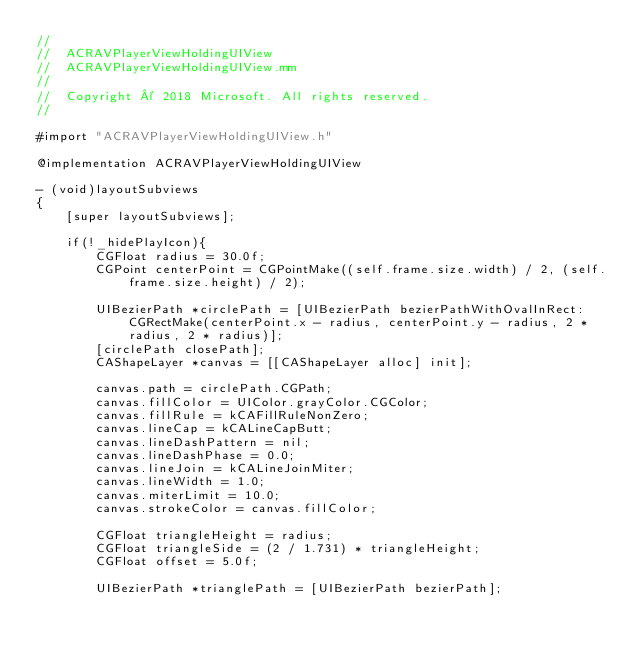<code> <loc_0><loc_0><loc_500><loc_500><_ObjectiveC_>//
//  ACRAVPlayerViewHoldingUIView
//  ACRAVPlayerViewHoldingUIView.mm
//
//  Copyright © 2018 Microsoft. All rights reserved.
//

#import "ACRAVPlayerViewHoldingUIView.h"

@implementation ACRAVPlayerViewHoldingUIView

- (void)layoutSubviews
{
    [super layoutSubviews];

    if(!_hidePlayIcon){
        CGFloat radius = 30.0f;
        CGPoint centerPoint = CGPointMake((self.frame.size.width) / 2, (self.frame.size.height) / 2);

        UIBezierPath *circlePath = [UIBezierPath bezierPathWithOvalInRect:CGRectMake(centerPoint.x - radius, centerPoint.y - radius, 2 * radius, 2 * radius)];
        [circlePath closePath];
        CAShapeLayer *canvas = [[CAShapeLayer alloc] init];

        canvas.path = circlePath.CGPath;
        canvas.fillColor = UIColor.grayColor.CGColor;
        canvas.fillRule = kCAFillRuleNonZero;
        canvas.lineCap = kCALineCapButt;
        canvas.lineDashPattern = nil;
        canvas.lineDashPhase = 0.0;
        canvas.lineJoin = kCALineJoinMiter;
        canvas.lineWidth = 1.0;
        canvas.miterLimit = 10.0;
        canvas.strokeColor = canvas.fillColor;

        CGFloat triangleHeight = radius;
        CGFloat triangleSide = (2 / 1.731) * triangleHeight;
        CGFloat offset = 5.0f;

        UIBezierPath *trianglePath = [UIBezierPath bezierPath];</code> 